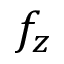<formula> <loc_0><loc_0><loc_500><loc_500>f _ { z }</formula> 